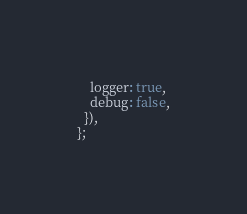<code> <loc_0><loc_0><loc_500><loc_500><_TypeScript_>    logger: true,
    debug: false,
  }),
};
</code> 